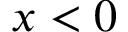Convert formula to latex. <formula><loc_0><loc_0><loc_500><loc_500>x < 0</formula> 